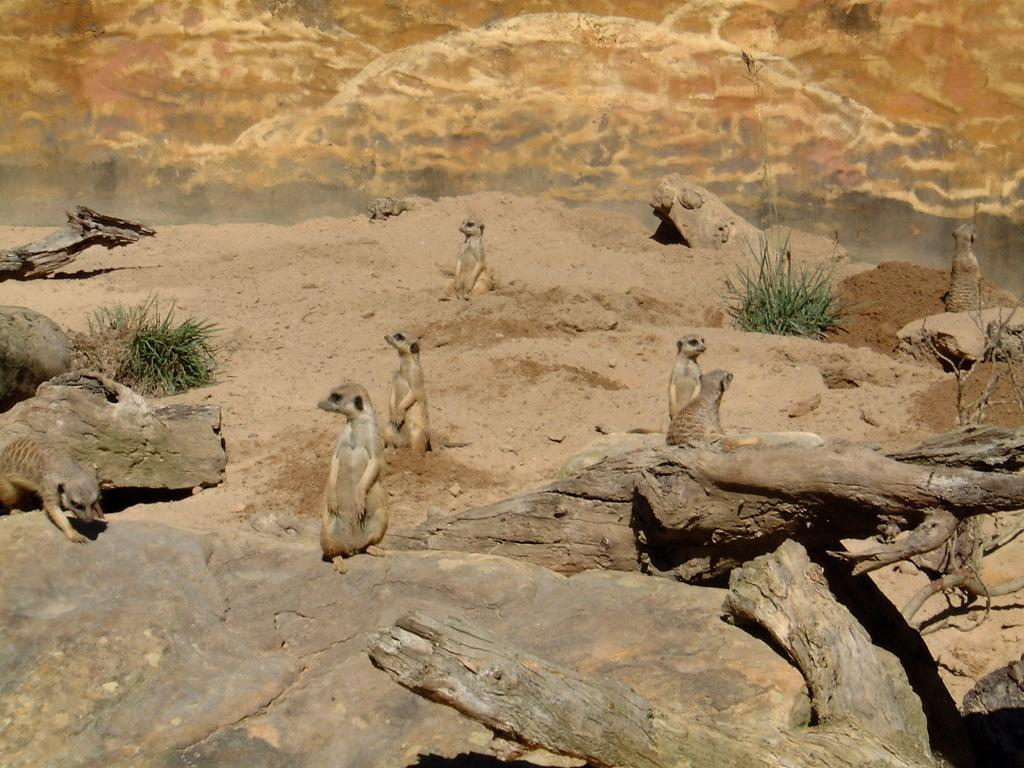What animals are in the image? There are Meerkats in the image. Where are the Meerkats located in the image? The Meerkats are in the middle of the image. What are some of the Meerkats doing in the image? Some Meerkats are sitting in the sand, with some sitting in the sand and others sitting on stones. What can be seen on the right side of the image? There is a big tree trunk on the right side of the image. What type of sock is hanging on the tree trunk in the image? There is no sock present in the image; it features Meerkats and a tree trunk. 